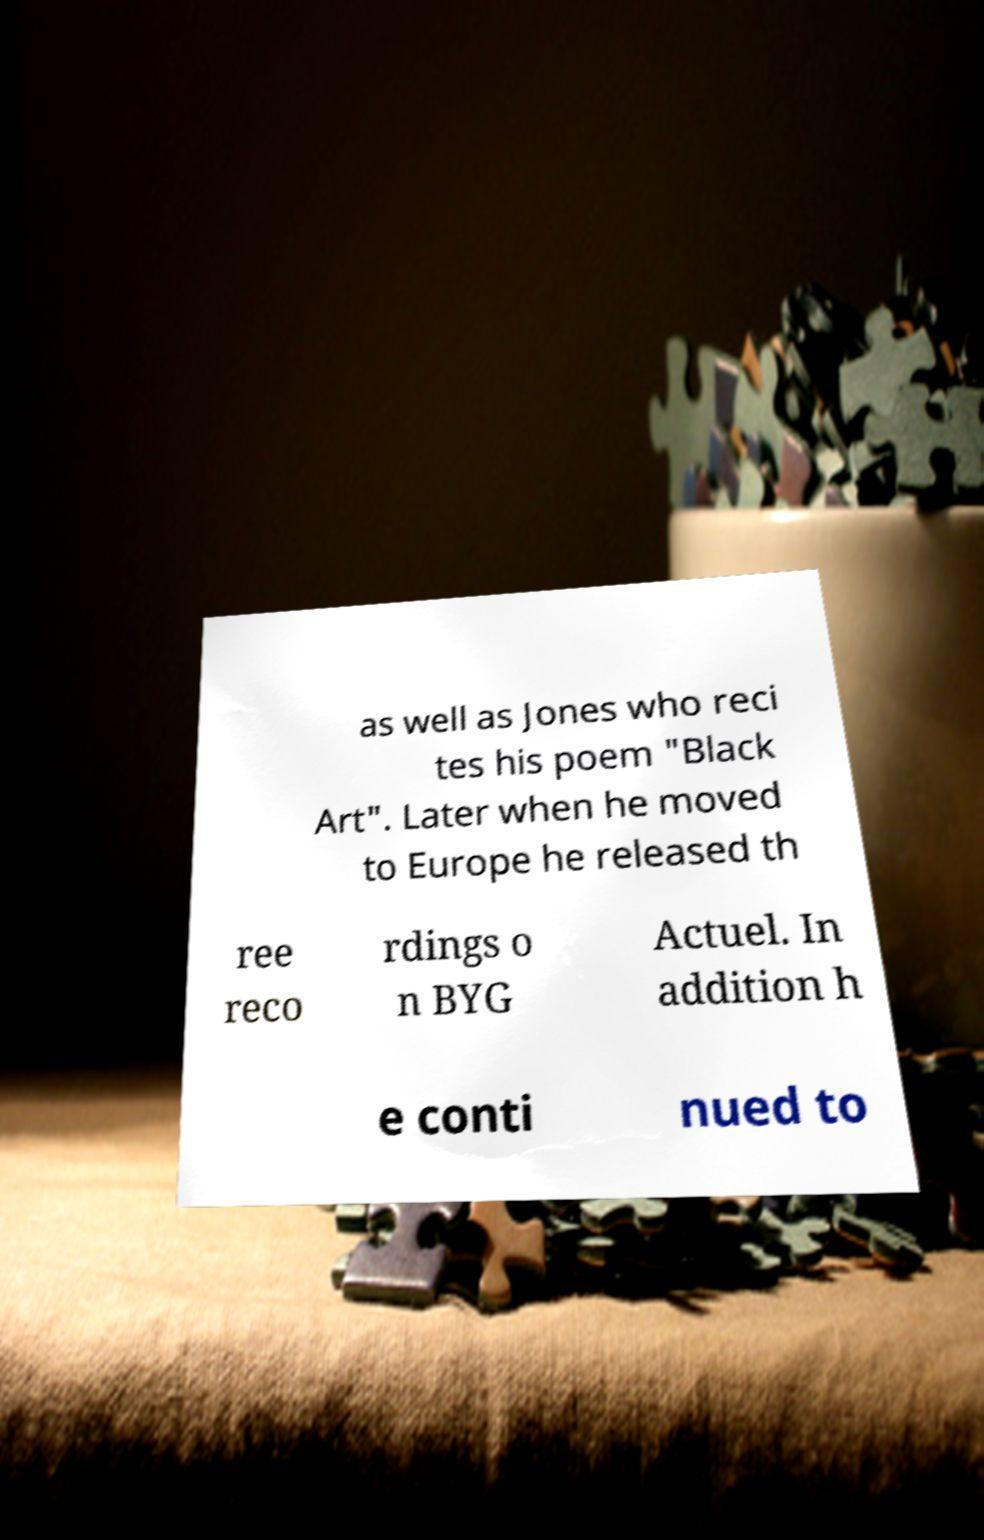Can you read and provide the text displayed in the image?This photo seems to have some interesting text. Can you extract and type it out for me? as well as Jones who reci tes his poem "Black Art". Later when he moved to Europe he released th ree reco rdings o n BYG Actuel. In addition h e conti nued to 